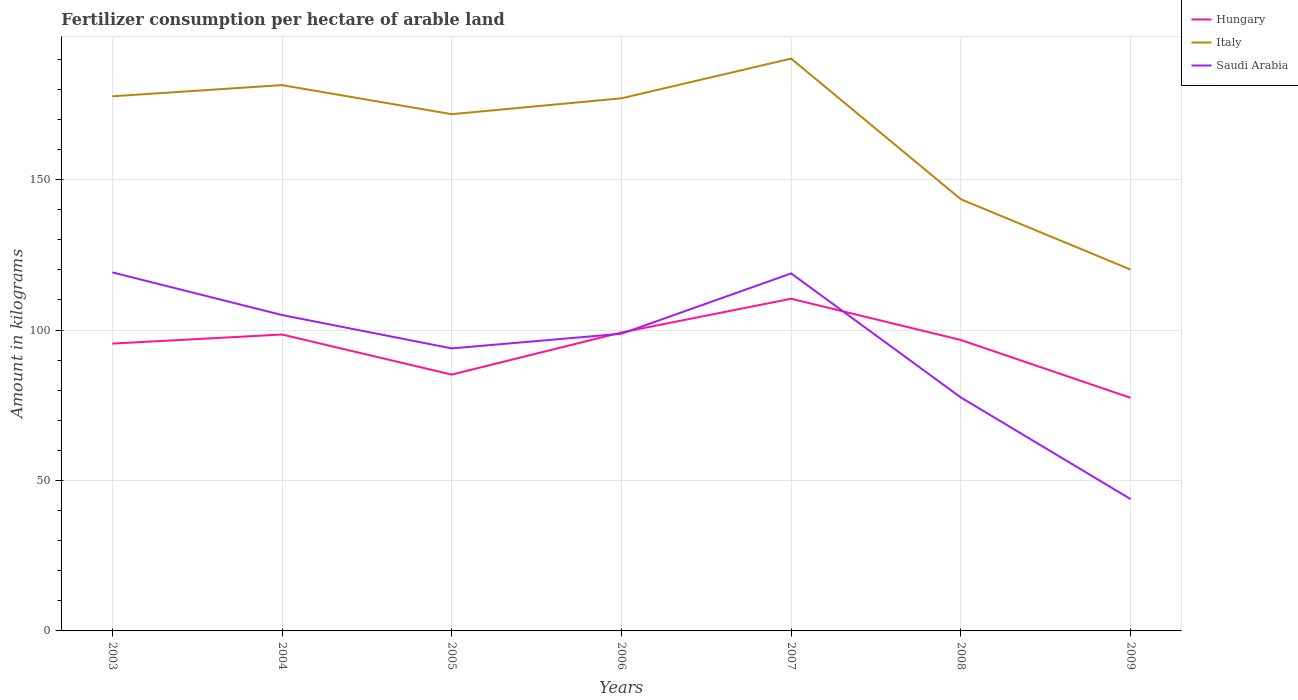Does the line corresponding to Italy intersect with the line corresponding to Saudi Arabia?
Your answer should be compact. No. Is the number of lines equal to the number of legend labels?
Give a very brief answer. Yes. Across all years, what is the maximum amount of fertilizer consumption in Saudi Arabia?
Keep it short and to the point. 43.82. In which year was the amount of fertilizer consumption in Saudi Arabia maximum?
Ensure brevity in your answer.  2009. What is the total amount of fertilizer consumption in Hungary in the graph?
Make the answer very short. 21.71. What is the difference between the highest and the second highest amount of fertilizer consumption in Saudi Arabia?
Your answer should be very brief. 75.36. How many lines are there?
Keep it short and to the point. 3. How many years are there in the graph?
Provide a succinct answer. 7. What is the difference between two consecutive major ticks on the Y-axis?
Provide a succinct answer. 50. Does the graph contain grids?
Provide a succinct answer. Yes. Where does the legend appear in the graph?
Your answer should be compact. Top right. How many legend labels are there?
Offer a very short reply. 3. What is the title of the graph?
Keep it short and to the point. Fertilizer consumption per hectare of arable land. What is the label or title of the Y-axis?
Make the answer very short. Amount in kilograms. What is the Amount in kilograms of Hungary in 2003?
Ensure brevity in your answer.  95.5. What is the Amount in kilograms of Italy in 2003?
Your response must be concise. 177.7. What is the Amount in kilograms of Saudi Arabia in 2003?
Offer a very short reply. 119.18. What is the Amount in kilograms in Hungary in 2004?
Provide a succinct answer. 98.52. What is the Amount in kilograms in Italy in 2004?
Keep it short and to the point. 181.42. What is the Amount in kilograms of Saudi Arabia in 2004?
Your answer should be very brief. 104.99. What is the Amount in kilograms of Hungary in 2005?
Keep it short and to the point. 85.2. What is the Amount in kilograms of Italy in 2005?
Offer a very short reply. 171.75. What is the Amount in kilograms of Saudi Arabia in 2005?
Your answer should be compact. 93.9. What is the Amount in kilograms of Hungary in 2006?
Provide a succinct answer. 99.2. What is the Amount in kilograms in Italy in 2006?
Your answer should be very brief. 177.03. What is the Amount in kilograms of Saudi Arabia in 2006?
Your answer should be compact. 98.78. What is the Amount in kilograms in Hungary in 2007?
Provide a succinct answer. 110.41. What is the Amount in kilograms of Italy in 2007?
Ensure brevity in your answer.  190.23. What is the Amount in kilograms in Saudi Arabia in 2007?
Keep it short and to the point. 118.82. What is the Amount in kilograms of Hungary in 2008?
Offer a very short reply. 96.7. What is the Amount in kilograms in Italy in 2008?
Provide a short and direct response. 143.48. What is the Amount in kilograms of Saudi Arabia in 2008?
Make the answer very short. 77.6. What is the Amount in kilograms of Hungary in 2009?
Keep it short and to the point. 77.48. What is the Amount in kilograms in Italy in 2009?
Provide a succinct answer. 120.11. What is the Amount in kilograms in Saudi Arabia in 2009?
Ensure brevity in your answer.  43.82. Across all years, what is the maximum Amount in kilograms in Hungary?
Make the answer very short. 110.41. Across all years, what is the maximum Amount in kilograms in Italy?
Give a very brief answer. 190.23. Across all years, what is the maximum Amount in kilograms in Saudi Arabia?
Your answer should be very brief. 119.18. Across all years, what is the minimum Amount in kilograms of Hungary?
Offer a terse response. 77.48. Across all years, what is the minimum Amount in kilograms in Italy?
Keep it short and to the point. 120.11. Across all years, what is the minimum Amount in kilograms in Saudi Arabia?
Ensure brevity in your answer.  43.82. What is the total Amount in kilograms of Hungary in the graph?
Your answer should be compact. 663. What is the total Amount in kilograms of Italy in the graph?
Keep it short and to the point. 1161.72. What is the total Amount in kilograms of Saudi Arabia in the graph?
Provide a succinct answer. 657.1. What is the difference between the Amount in kilograms in Hungary in 2003 and that in 2004?
Your answer should be very brief. -3.02. What is the difference between the Amount in kilograms of Italy in 2003 and that in 2004?
Your response must be concise. -3.72. What is the difference between the Amount in kilograms of Saudi Arabia in 2003 and that in 2004?
Offer a terse response. 14.19. What is the difference between the Amount in kilograms of Hungary in 2003 and that in 2005?
Offer a terse response. 10.3. What is the difference between the Amount in kilograms of Italy in 2003 and that in 2005?
Make the answer very short. 5.95. What is the difference between the Amount in kilograms in Saudi Arabia in 2003 and that in 2005?
Make the answer very short. 25.28. What is the difference between the Amount in kilograms in Hungary in 2003 and that in 2006?
Offer a terse response. -3.7. What is the difference between the Amount in kilograms of Italy in 2003 and that in 2006?
Your response must be concise. 0.67. What is the difference between the Amount in kilograms of Saudi Arabia in 2003 and that in 2006?
Offer a very short reply. 20.4. What is the difference between the Amount in kilograms of Hungary in 2003 and that in 2007?
Your response must be concise. -14.91. What is the difference between the Amount in kilograms in Italy in 2003 and that in 2007?
Provide a succinct answer. -12.53. What is the difference between the Amount in kilograms in Saudi Arabia in 2003 and that in 2007?
Offer a very short reply. 0.36. What is the difference between the Amount in kilograms of Hungary in 2003 and that in 2008?
Make the answer very short. -1.2. What is the difference between the Amount in kilograms of Italy in 2003 and that in 2008?
Keep it short and to the point. 34.23. What is the difference between the Amount in kilograms of Saudi Arabia in 2003 and that in 2008?
Keep it short and to the point. 41.59. What is the difference between the Amount in kilograms in Hungary in 2003 and that in 2009?
Your response must be concise. 18.01. What is the difference between the Amount in kilograms in Italy in 2003 and that in 2009?
Your answer should be compact. 57.59. What is the difference between the Amount in kilograms in Saudi Arabia in 2003 and that in 2009?
Make the answer very short. 75.36. What is the difference between the Amount in kilograms in Hungary in 2004 and that in 2005?
Provide a succinct answer. 13.32. What is the difference between the Amount in kilograms in Italy in 2004 and that in 2005?
Ensure brevity in your answer.  9.66. What is the difference between the Amount in kilograms in Saudi Arabia in 2004 and that in 2005?
Your answer should be compact. 11.09. What is the difference between the Amount in kilograms of Hungary in 2004 and that in 2006?
Your answer should be compact. -0.67. What is the difference between the Amount in kilograms in Italy in 2004 and that in 2006?
Your answer should be very brief. 4.39. What is the difference between the Amount in kilograms of Saudi Arabia in 2004 and that in 2006?
Your answer should be compact. 6.21. What is the difference between the Amount in kilograms in Hungary in 2004 and that in 2007?
Your answer should be very brief. -11.89. What is the difference between the Amount in kilograms in Italy in 2004 and that in 2007?
Ensure brevity in your answer.  -8.81. What is the difference between the Amount in kilograms in Saudi Arabia in 2004 and that in 2007?
Your response must be concise. -13.83. What is the difference between the Amount in kilograms of Hungary in 2004 and that in 2008?
Provide a short and direct response. 1.82. What is the difference between the Amount in kilograms in Italy in 2004 and that in 2008?
Your response must be concise. 37.94. What is the difference between the Amount in kilograms in Saudi Arabia in 2004 and that in 2008?
Provide a succinct answer. 27.4. What is the difference between the Amount in kilograms in Hungary in 2004 and that in 2009?
Ensure brevity in your answer.  21.04. What is the difference between the Amount in kilograms in Italy in 2004 and that in 2009?
Provide a short and direct response. 61.31. What is the difference between the Amount in kilograms of Saudi Arabia in 2004 and that in 2009?
Provide a succinct answer. 61.17. What is the difference between the Amount in kilograms of Hungary in 2005 and that in 2006?
Your answer should be compact. -14. What is the difference between the Amount in kilograms of Italy in 2005 and that in 2006?
Your answer should be compact. -5.28. What is the difference between the Amount in kilograms of Saudi Arabia in 2005 and that in 2006?
Give a very brief answer. -4.88. What is the difference between the Amount in kilograms of Hungary in 2005 and that in 2007?
Make the answer very short. -25.21. What is the difference between the Amount in kilograms in Italy in 2005 and that in 2007?
Offer a terse response. -18.48. What is the difference between the Amount in kilograms in Saudi Arabia in 2005 and that in 2007?
Your answer should be compact. -24.92. What is the difference between the Amount in kilograms in Hungary in 2005 and that in 2008?
Your answer should be very brief. -11.5. What is the difference between the Amount in kilograms of Italy in 2005 and that in 2008?
Provide a succinct answer. 28.28. What is the difference between the Amount in kilograms in Saudi Arabia in 2005 and that in 2008?
Make the answer very short. 16.31. What is the difference between the Amount in kilograms in Hungary in 2005 and that in 2009?
Give a very brief answer. 7.72. What is the difference between the Amount in kilograms in Italy in 2005 and that in 2009?
Your response must be concise. 51.64. What is the difference between the Amount in kilograms in Saudi Arabia in 2005 and that in 2009?
Offer a very short reply. 50.08. What is the difference between the Amount in kilograms in Hungary in 2006 and that in 2007?
Keep it short and to the point. -11.21. What is the difference between the Amount in kilograms of Italy in 2006 and that in 2007?
Offer a very short reply. -13.2. What is the difference between the Amount in kilograms of Saudi Arabia in 2006 and that in 2007?
Provide a short and direct response. -20.04. What is the difference between the Amount in kilograms of Hungary in 2006 and that in 2008?
Your response must be concise. 2.49. What is the difference between the Amount in kilograms in Italy in 2006 and that in 2008?
Offer a terse response. 33.56. What is the difference between the Amount in kilograms of Saudi Arabia in 2006 and that in 2008?
Provide a succinct answer. 21.19. What is the difference between the Amount in kilograms in Hungary in 2006 and that in 2009?
Make the answer very short. 21.71. What is the difference between the Amount in kilograms in Italy in 2006 and that in 2009?
Provide a short and direct response. 56.92. What is the difference between the Amount in kilograms in Saudi Arabia in 2006 and that in 2009?
Provide a short and direct response. 54.96. What is the difference between the Amount in kilograms of Hungary in 2007 and that in 2008?
Ensure brevity in your answer.  13.71. What is the difference between the Amount in kilograms in Italy in 2007 and that in 2008?
Your response must be concise. 46.75. What is the difference between the Amount in kilograms in Saudi Arabia in 2007 and that in 2008?
Your response must be concise. 41.23. What is the difference between the Amount in kilograms in Hungary in 2007 and that in 2009?
Keep it short and to the point. 32.93. What is the difference between the Amount in kilograms in Italy in 2007 and that in 2009?
Make the answer very short. 70.12. What is the difference between the Amount in kilograms in Saudi Arabia in 2007 and that in 2009?
Provide a succinct answer. 75. What is the difference between the Amount in kilograms in Hungary in 2008 and that in 2009?
Your answer should be very brief. 19.22. What is the difference between the Amount in kilograms of Italy in 2008 and that in 2009?
Offer a terse response. 23.36. What is the difference between the Amount in kilograms in Saudi Arabia in 2008 and that in 2009?
Your answer should be very brief. 33.77. What is the difference between the Amount in kilograms in Hungary in 2003 and the Amount in kilograms in Italy in 2004?
Provide a succinct answer. -85.92. What is the difference between the Amount in kilograms of Hungary in 2003 and the Amount in kilograms of Saudi Arabia in 2004?
Give a very brief answer. -9.49. What is the difference between the Amount in kilograms of Italy in 2003 and the Amount in kilograms of Saudi Arabia in 2004?
Provide a succinct answer. 72.71. What is the difference between the Amount in kilograms in Hungary in 2003 and the Amount in kilograms in Italy in 2005?
Your answer should be very brief. -76.26. What is the difference between the Amount in kilograms in Hungary in 2003 and the Amount in kilograms in Saudi Arabia in 2005?
Offer a terse response. 1.59. What is the difference between the Amount in kilograms in Italy in 2003 and the Amount in kilograms in Saudi Arabia in 2005?
Offer a terse response. 83.8. What is the difference between the Amount in kilograms in Hungary in 2003 and the Amount in kilograms in Italy in 2006?
Keep it short and to the point. -81.53. What is the difference between the Amount in kilograms of Hungary in 2003 and the Amount in kilograms of Saudi Arabia in 2006?
Your answer should be compact. -3.29. What is the difference between the Amount in kilograms of Italy in 2003 and the Amount in kilograms of Saudi Arabia in 2006?
Give a very brief answer. 78.92. What is the difference between the Amount in kilograms of Hungary in 2003 and the Amount in kilograms of Italy in 2007?
Provide a short and direct response. -94.73. What is the difference between the Amount in kilograms in Hungary in 2003 and the Amount in kilograms in Saudi Arabia in 2007?
Offer a terse response. -23.33. What is the difference between the Amount in kilograms of Italy in 2003 and the Amount in kilograms of Saudi Arabia in 2007?
Give a very brief answer. 58.88. What is the difference between the Amount in kilograms in Hungary in 2003 and the Amount in kilograms in Italy in 2008?
Provide a short and direct response. -47.98. What is the difference between the Amount in kilograms of Hungary in 2003 and the Amount in kilograms of Saudi Arabia in 2008?
Offer a very short reply. 17.9. What is the difference between the Amount in kilograms of Italy in 2003 and the Amount in kilograms of Saudi Arabia in 2008?
Give a very brief answer. 100.11. What is the difference between the Amount in kilograms of Hungary in 2003 and the Amount in kilograms of Italy in 2009?
Ensure brevity in your answer.  -24.61. What is the difference between the Amount in kilograms in Hungary in 2003 and the Amount in kilograms in Saudi Arabia in 2009?
Provide a succinct answer. 51.67. What is the difference between the Amount in kilograms in Italy in 2003 and the Amount in kilograms in Saudi Arabia in 2009?
Offer a terse response. 133.88. What is the difference between the Amount in kilograms in Hungary in 2004 and the Amount in kilograms in Italy in 2005?
Your answer should be very brief. -73.23. What is the difference between the Amount in kilograms in Hungary in 2004 and the Amount in kilograms in Saudi Arabia in 2005?
Your response must be concise. 4.62. What is the difference between the Amount in kilograms in Italy in 2004 and the Amount in kilograms in Saudi Arabia in 2005?
Keep it short and to the point. 87.52. What is the difference between the Amount in kilograms in Hungary in 2004 and the Amount in kilograms in Italy in 2006?
Ensure brevity in your answer.  -78.51. What is the difference between the Amount in kilograms in Hungary in 2004 and the Amount in kilograms in Saudi Arabia in 2006?
Provide a succinct answer. -0.26. What is the difference between the Amount in kilograms in Italy in 2004 and the Amount in kilograms in Saudi Arabia in 2006?
Provide a succinct answer. 82.64. What is the difference between the Amount in kilograms of Hungary in 2004 and the Amount in kilograms of Italy in 2007?
Provide a succinct answer. -91.71. What is the difference between the Amount in kilograms in Hungary in 2004 and the Amount in kilograms in Saudi Arabia in 2007?
Provide a succinct answer. -20.3. What is the difference between the Amount in kilograms of Italy in 2004 and the Amount in kilograms of Saudi Arabia in 2007?
Offer a terse response. 62.59. What is the difference between the Amount in kilograms in Hungary in 2004 and the Amount in kilograms in Italy in 2008?
Provide a succinct answer. -44.96. What is the difference between the Amount in kilograms in Hungary in 2004 and the Amount in kilograms in Saudi Arabia in 2008?
Provide a succinct answer. 20.93. What is the difference between the Amount in kilograms of Italy in 2004 and the Amount in kilograms of Saudi Arabia in 2008?
Your answer should be compact. 103.82. What is the difference between the Amount in kilograms of Hungary in 2004 and the Amount in kilograms of Italy in 2009?
Offer a very short reply. -21.59. What is the difference between the Amount in kilograms of Hungary in 2004 and the Amount in kilograms of Saudi Arabia in 2009?
Keep it short and to the point. 54.7. What is the difference between the Amount in kilograms of Italy in 2004 and the Amount in kilograms of Saudi Arabia in 2009?
Make the answer very short. 137.59. What is the difference between the Amount in kilograms of Hungary in 2005 and the Amount in kilograms of Italy in 2006?
Keep it short and to the point. -91.83. What is the difference between the Amount in kilograms of Hungary in 2005 and the Amount in kilograms of Saudi Arabia in 2006?
Provide a succinct answer. -13.58. What is the difference between the Amount in kilograms of Italy in 2005 and the Amount in kilograms of Saudi Arabia in 2006?
Make the answer very short. 72.97. What is the difference between the Amount in kilograms of Hungary in 2005 and the Amount in kilograms of Italy in 2007?
Provide a succinct answer. -105.03. What is the difference between the Amount in kilograms of Hungary in 2005 and the Amount in kilograms of Saudi Arabia in 2007?
Provide a succinct answer. -33.63. What is the difference between the Amount in kilograms in Italy in 2005 and the Amount in kilograms in Saudi Arabia in 2007?
Ensure brevity in your answer.  52.93. What is the difference between the Amount in kilograms in Hungary in 2005 and the Amount in kilograms in Italy in 2008?
Ensure brevity in your answer.  -58.28. What is the difference between the Amount in kilograms of Hungary in 2005 and the Amount in kilograms of Saudi Arabia in 2008?
Keep it short and to the point. 7.6. What is the difference between the Amount in kilograms of Italy in 2005 and the Amount in kilograms of Saudi Arabia in 2008?
Offer a very short reply. 94.16. What is the difference between the Amount in kilograms in Hungary in 2005 and the Amount in kilograms in Italy in 2009?
Make the answer very short. -34.91. What is the difference between the Amount in kilograms of Hungary in 2005 and the Amount in kilograms of Saudi Arabia in 2009?
Keep it short and to the point. 41.38. What is the difference between the Amount in kilograms in Italy in 2005 and the Amount in kilograms in Saudi Arabia in 2009?
Provide a short and direct response. 127.93. What is the difference between the Amount in kilograms in Hungary in 2006 and the Amount in kilograms in Italy in 2007?
Your response must be concise. -91.03. What is the difference between the Amount in kilograms in Hungary in 2006 and the Amount in kilograms in Saudi Arabia in 2007?
Provide a succinct answer. -19.63. What is the difference between the Amount in kilograms of Italy in 2006 and the Amount in kilograms of Saudi Arabia in 2007?
Give a very brief answer. 58.21. What is the difference between the Amount in kilograms of Hungary in 2006 and the Amount in kilograms of Italy in 2008?
Provide a short and direct response. -44.28. What is the difference between the Amount in kilograms in Hungary in 2006 and the Amount in kilograms in Saudi Arabia in 2008?
Make the answer very short. 21.6. What is the difference between the Amount in kilograms in Italy in 2006 and the Amount in kilograms in Saudi Arabia in 2008?
Your response must be concise. 99.44. What is the difference between the Amount in kilograms of Hungary in 2006 and the Amount in kilograms of Italy in 2009?
Provide a short and direct response. -20.92. What is the difference between the Amount in kilograms in Hungary in 2006 and the Amount in kilograms in Saudi Arabia in 2009?
Offer a very short reply. 55.37. What is the difference between the Amount in kilograms of Italy in 2006 and the Amount in kilograms of Saudi Arabia in 2009?
Keep it short and to the point. 133.21. What is the difference between the Amount in kilograms of Hungary in 2007 and the Amount in kilograms of Italy in 2008?
Provide a short and direct response. -33.07. What is the difference between the Amount in kilograms in Hungary in 2007 and the Amount in kilograms in Saudi Arabia in 2008?
Provide a short and direct response. 32.81. What is the difference between the Amount in kilograms of Italy in 2007 and the Amount in kilograms of Saudi Arabia in 2008?
Offer a very short reply. 112.63. What is the difference between the Amount in kilograms of Hungary in 2007 and the Amount in kilograms of Italy in 2009?
Ensure brevity in your answer.  -9.7. What is the difference between the Amount in kilograms in Hungary in 2007 and the Amount in kilograms in Saudi Arabia in 2009?
Keep it short and to the point. 66.59. What is the difference between the Amount in kilograms of Italy in 2007 and the Amount in kilograms of Saudi Arabia in 2009?
Give a very brief answer. 146.41. What is the difference between the Amount in kilograms of Hungary in 2008 and the Amount in kilograms of Italy in 2009?
Keep it short and to the point. -23.41. What is the difference between the Amount in kilograms of Hungary in 2008 and the Amount in kilograms of Saudi Arabia in 2009?
Ensure brevity in your answer.  52.88. What is the difference between the Amount in kilograms of Italy in 2008 and the Amount in kilograms of Saudi Arabia in 2009?
Make the answer very short. 99.65. What is the average Amount in kilograms of Hungary per year?
Offer a very short reply. 94.71. What is the average Amount in kilograms in Italy per year?
Offer a very short reply. 165.96. What is the average Amount in kilograms in Saudi Arabia per year?
Offer a terse response. 93.87. In the year 2003, what is the difference between the Amount in kilograms of Hungary and Amount in kilograms of Italy?
Keep it short and to the point. -82.21. In the year 2003, what is the difference between the Amount in kilograms in Hungary and Amount in kilograms in Saudi Arabia?
Your answer should be very brief. -23.68. In the year 2003, what is the difference between the Amount in kilograms of Italy and Amount in kilograms of Saudi Arabia?
Keep it short and to the point. 58.52. In the year 2004, what is the difference between the Amount in kilograms of Hungary and Amount in kilograms of Italy?
Your response must be concise. -82.9. In the year 2004, what is the difference between the Amount in kilograms in Hungary and Amount in kilograms in Saudi Arabia?
Ensure brevity in your answer.  -6.47. In the year 2004, what is the difference between the Amount in kilograms in Italy and Amount in kilograms in Saudi Arabia?
Your response must be concise. 76.43. In the year 2005, what is the difference between the Amount in kilograms in Hungary and Amount in kilograms in Italy?
Your answer should be compact. -86.55. In the year 2005, what is the difference between the Amount in kilograms in Hungary and Amount in kilograms in Saudi Arabia?
Keep it short and to the point. -8.7. In the year 2005, what is the difference between the Amount in kilograms in Italy and Amount in kilograms in Saudi Arabia?
Make the answer very short. 77.85. In the year 2006, what is the difference between the Amount in kilograms of Hungary and Amount in kilograms of Italy?
Make the answer very short. -77.84. In the year 2006, what is the difference between the Amount in kilograms of Hungary and Amount in kilograms of Saudi Arabia?
Provide a short and direct response. 0.41. In the year 2006, what is the difference between the Amount in kilograms of Italy and Amount in kilograms of Saudi Arabia?
Provide a succinct answer. 78.25. In the year 2007, what is the difference between the Amount in kilograms of Hungary and Amount in kilograms of Italy?
Give a very brief answer. -79.82. In the year 2007, what is the difference between the Amount in kilograms of Hungary and Amount in kilograms of Saudi Arabia?
Your answer should be very brief. -8.42. In the year 2007, what is the difference between the Amount in kilograms in Italy and Amount in kilograms in Saudi Arabia?
Give a very brief answer. 71.41. In the year 2008, what is the difference between the Amount in kilograms of Hungary and Amount in kilograms of Italy?
Provide a succinct answer. -46.78. In the year 2008, what is the difference between the Amount in kilograms of Hungary and Amount in kilograms of Saudi Arabia?
Offer a very short reply. 19.11. In the year 2008, what is the difference between the Amount in kilograms of Italy and Amount in kilograms of Saudi Arabia?
Keep it short and to the point. 65.88. In the year 2009, what is the difference between the Amount in kilograms of Hungary and Amount in kilograms of Italy?
Your answer should be very brief. -42.63. In the year 2009, what is the difference between the Amount in kilograms in Hungary and Amount in kilograms in Saudi Arabia?
Your response must be concise. 33.66. In the year 2009, what is the difference between the Amount in kilograms of Italy and Amount in kilograms of Saudi Arabia?
Ensure brevity in your answer.  76.29. What is the ratio of the Amount in kilograms in Hungary in 2003 to that in 2004?
Ensure brevity in your answer.  0.97. What is the ratio of the Amount in kilograms in Italy in 2003 to that in 2004?
Provide a short and direct response. 0.98. What is the ratio of the Amount in kilograms in Saudi Arabia in 2003 to that in 2004?
Offer a very short reply. 1.14. What is the ratio of the Amount in kilograms of Hungary in 2003 to that in 2005?
Keep it short and to the point. 1.12. What is the ratio of the Amount in kilograms in Italy in 2003 to that in 2005?
Your response must be concise. 1.03. What is the ratio of the Amount in kilograms of Saudi Arabia in 2003 to that in 2005?
Keep it short and to the point. 1.27. What is the ratio of the Amount in kilograms of Hungary in 2003 to that in 2006?
Give a very brief answer. 0.96. What is the ratio of the Amount in kilograms of Italy in 2003 to that in 2006?
Provide a succinct answer. 1. What is the ratio of the Amount in kilograms of Saudi Arabia in 2003 to that in 2006?
Keep it short and to the point. 1.21. What is the ratio of the Amount in kilograms of Hungary in 2003 to that in 2007?
Offer a very short reply. 0.86. What is the ratio of the Amount in kilograms in Italy in 2003 to that in 2007?
Keep it short and to the point. 0.93. What is the ratio of the Amount in kilograms of Saudi Arabia in 2003 to that in 2007?
Your response must be concise. 1. What is the ratio of the Amount in kilograms of Hungary in 2003 to that in 2008?
Your response must be concise. 0.99. What is the ratio of the Amount in kilograms in Italy in 2003 to that in 2008?
Ensure brevity in your answer.  1.24. What is the ratio of the Amount in kilograms in Saudi Arabia in 2003 to that in 2008?
Offer a very short reply. 1.54. What is the ratio of the Amount in kilograms of Hungary in 2003 to that in 2009?
Provide a succinct answer. 1.23. What is the ratio of the Amount in kilograms of Italy in 2003 to that in 2009?
Keep it short and to the point. 1.48. What is the ratio of the Amount in kilograms of Saudi Arabia in 2003 to that in 2009?
Your answer should be very brief. 2.72. What is the ratio of the Amount in kilograms of Hungary in 2004 to that in 2005?
Your answer should be compact. 1.16. What is the ratio of the Amount in kilograms of Italy in 2004 to that in 2005?
Ensure brevity in your answer.  1.06. What is the ratio of the Amount in kilograms in Saudi Arabia in 2004 to that in 2005?
Offer a terse response. 1.12. What is the ratio of the Amount in kilograms in Hungary in 2004 to that in 2006?
Offer a very short reply. 0.99. What is the ratio of the Amount in kilograms of Italy in 2004 to that in 2006?
Provide a short and direct response. 1.02. What is the ratio of the Amount in kilograms of Saudi Arabia in 2004 to that in 2006?
Your answer should be compact. 1.06. What is the ratio of the Amount in kilograms of Hungary in 2004 to that in 2007?
Offer a very short reply. 0.89. What is the ratio of the Amount in kilograms of Italy in 2004 to that in 2007?
Your answer should be compact. 0.95. What is the ratio of the Amount in kilograms in Saudi Arabia in 2004 to that in 2007?
Your response must be concise. 0.88. What is the ratio of the Amount in kilograms of Hungary in 2004 to that in 2008?
Provide a short and direct response. 1.02. What is the ratio of the Amount in kilograms of Italy in 2004 to that in 2008?
Make the answer very short. 1.26. What is the ratio of the Amount in kilograms in Saudi Arabia in 2004 to that in 2008?
Provide a succinct answer. 1.35. What is the ratio of the Amount in kilograms of Hungary in 2004 to that in 2009?
Ensure brevity in your answer.  1.27. What is the ratio of the Amount in kilograms of Italy in 2004 to that in 2009?
Offer a terse response. 1.51. What is the ratio of the Amount in kilograms in Saudi Arabia in 2004 to that in 2009?
Make the answer very short. 2.4. What is the ratio of the Amount in kilograms in Hungary in 2005 to that in 2006?
Your response must be concise. 0.86. What is the ratio of the Amount in kilograms of Italy in 2005 to that in 2006?
Give a very brief answer. 0.97. What is the ratio of the Amount in kilograms in Saudi Arabia in 2005 to that in 2006?
Your response must be concise. 0.95. What is the ratio of the Amount in kilograms of Hungary in 2005 to that in 2007?
Offer a very short reply. 0.77. What is the ratio of the Amount in kilograms of Italy in 2005 to that in 2007?
Your answer should be compact. 0.9. What is the ratio of the Amount in kilograms of Saudi Arabia in 2005 to that in 2007?
Your response must be concise. 0.79. What is the ratio of the Amount in kilograms in Hungary in 2005 to that in 2008?
Your response must be concise. 0.88. What is the ratio of the Amount in kilograms of Italy in 2005 to that in 2008?
Keep it short and to the point. 1.2. What is the ratio of the Amount in kilograms of Saudi Arabia in 2005 to that in 2008?
Your answer should be compact. 1.21. What is the ratio of the Amount in kilograms in Hungary in 2005 to that in 2009?
Give a very brief answer. 1.1. What is the ratio of the Amount in kilograms of Italy in 2005 to that in 2009?
Ensure brevity in your answer.  1.43. What is the ratio of the Amount in kilograms in Saudi Arabia in 2005 to that in 2009?
Provide a succinct answer. 2.14. What is the ratio of the Amount in kilograms in Hungary in 2006 to that in 2007?
Give a very brief answer. 0.9. What is the ratio of the Amount in kilograms of Italy in 2006 to that in 2007?
Provide a succinct answer. 0.93. What is the ratio of the Amount in kilograms of Saudi Arabia in 2006 to that in 2007?
Ensure brevity in your answer.  0.83. What is the ratio of the Amount in kilograms in Hungary in 2006 to that in 2008?
Your response must be concise. 1.03. What is the ratio of the Amount in kilograms of Italy in 2006 to that in 2008?
Ensure brevity in your answer.  1.23. What is the ratio of the Amount in kilograms of Saudi Arabia in 2006 to that in 2008?
Provide a succinct answer. 1.27. What is the ratio of the Amount in kilograms in Hungary in 2006 to that in 2009?
Provide a short and direct response. 1.28. What is the ratio of the Amount in kilograms of Italy in 2006 to that in 2009?
Your answer should be very brief. 1.47. What is the ratio of the Amount in kilograms of Saudi Arabia in 2006 to that in 2009?
Keep it short and to the point. 2.25. What is the ratio of the Amount in kilograms in Hungary in 2007 to that in 2008?
Ensure brevity in your answer.  1.14. What is the ratio of the Amount in kilograms in Italy in 2007 to that in 2008?
Provide a short and direct response. 1.33. What is the ratio of the Amount in kilograms of Saudi Arabia in 2007 to that in 2008?
Provide a short and direct response. 1.53. What is the ratio of the Amount in kilograms of Hungary in 2007 to that in 2009?
Offer a very short reply. 1.43. What is the ratio of the Amount in kilograms in Italy in 2007 to that in 2009?
Provide a short and direct response. 1.58. What is the ratio of the Amount in kilograms in Saudi Arabia in 2007 to that in 2009?
Your response must be concise. 2.71. What is the ratio of the Amount in kilograms of Hungary in 2008 to that in 2009?
Offer a terse response. 1.25. What is the ratio of the Amount in kilograms of Italy in 2008 to that in 2009?
Your answer should be compact. 1.19. What is the ratio of the Amount in kilograms in Saudi Arabia in 2008 to that in 2009?
Your answer should be very brief. 1.77. What is the difference between the highest and the second highest Amount in kilograms of Hungary?
Keep it short and to the point. 11.21. What is the difference between the highest and the second highest Amount in kilograms of Italy?
Provide a short and direct response. 8.81. What is the difference between the highest and the second highest Amount in kilograms of Saudi Arabia?
Your response must be concise. 0.36. What is the difference between the highest and the lowest Amount in kilograms of Hungary?
Ensure brevity in your answer.  32.93. What is the difference between the highest and the lowest Amount in kilograms in Italy?
Offer a very short reply. 70.12. What is the difference between the highest and the lowest Amount in kilograms in Saudi Arabia?
Keep it short and to the point. 75.36. 